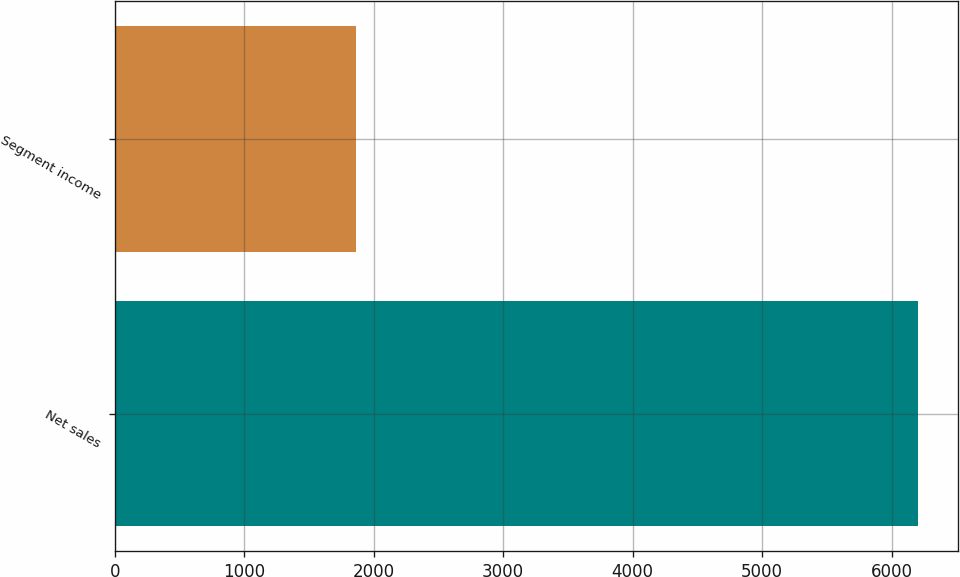<chart> <loc_0><loc_0><loc_500><loc_500><bar_chart><fcel>Net sales<fcel>Segment income<nl><fcel>6200.1<fcel>1862.6<nl></chart> 